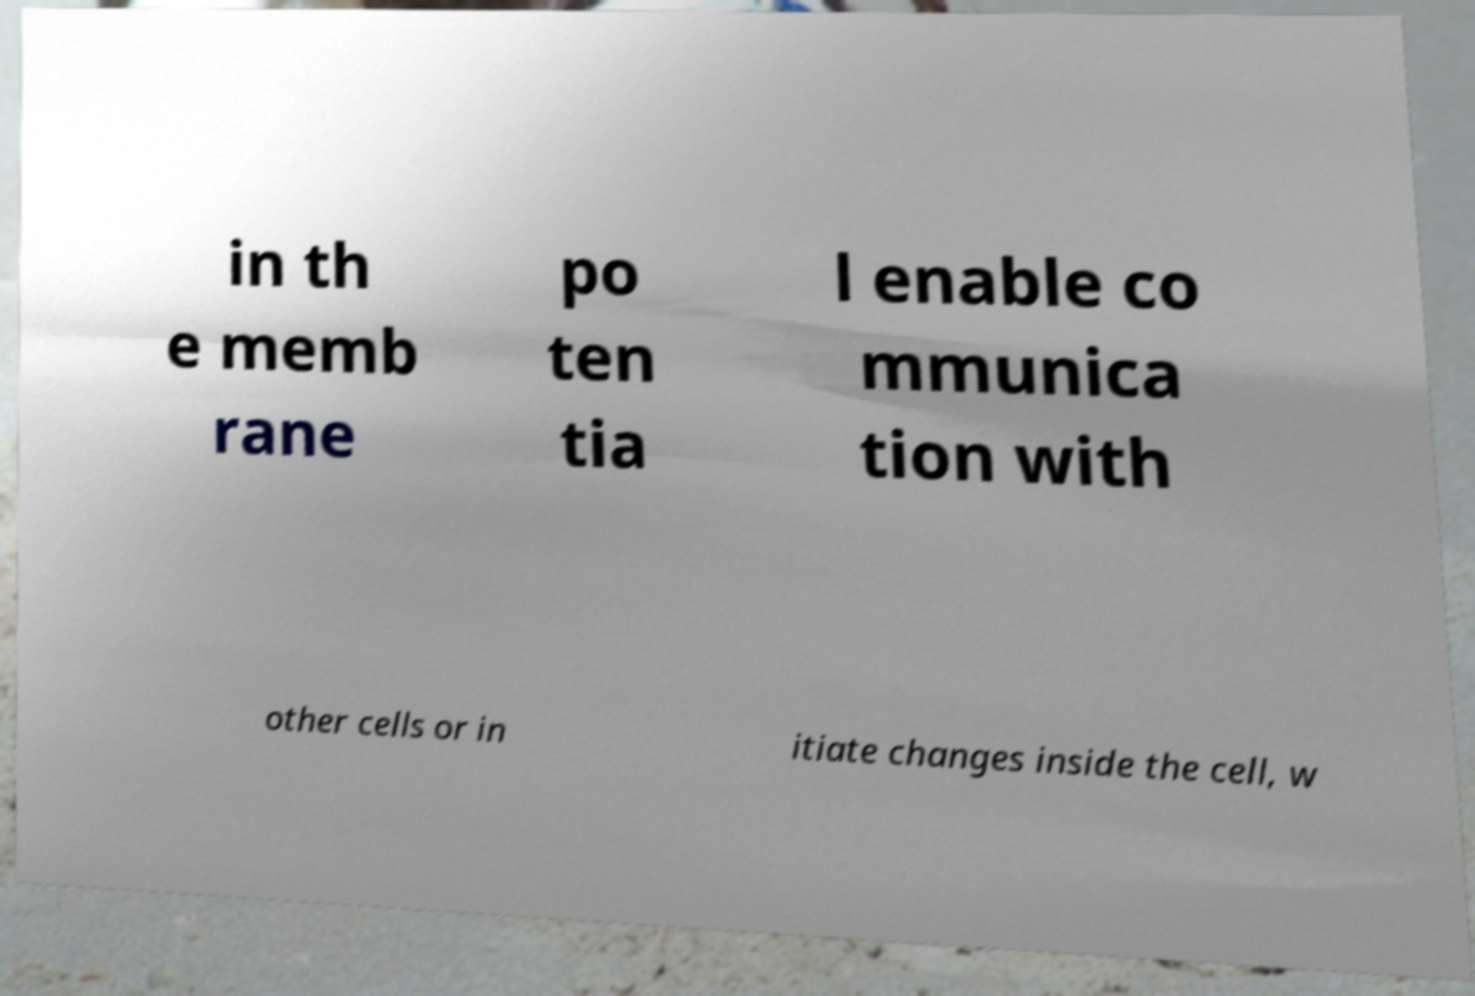Can you accurately transcribe the text from the provided image for me? in th e memb rane po ten tia l enable co mmunica tion with other cells or in itiate changes inside the cell, w 